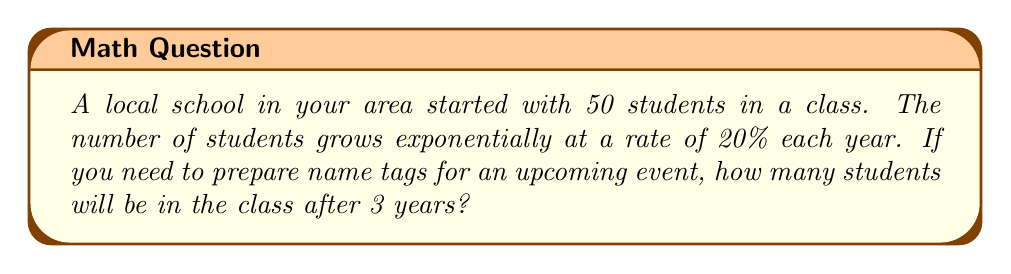Could you help me with this problem? Let's approach this step-by-step:

1) The initial number of students is 50.

2) The growth rate is 20% per year, which means the growth factor is $1 + 20\% = 1.20$.

3) We need to calculate the number of students after 3 years.

4) The formula for exponential growth is:
   $$A = P(1 + r)^t$$
   where:
   $A$ is the final amount
   $P$ is the initial amount
   $r$ is the growth rate (as a decimal)
   $t$ is the time period

5) Plugging in our values:
   $$A = 50(1.20)^3$$

6) Let's calculate this:
   $$A = 50 \times 1.728 = 86.4$$

7) Since we can't have a fractional number of students, we round up to the nearest whole number.
Answer: 87 students 